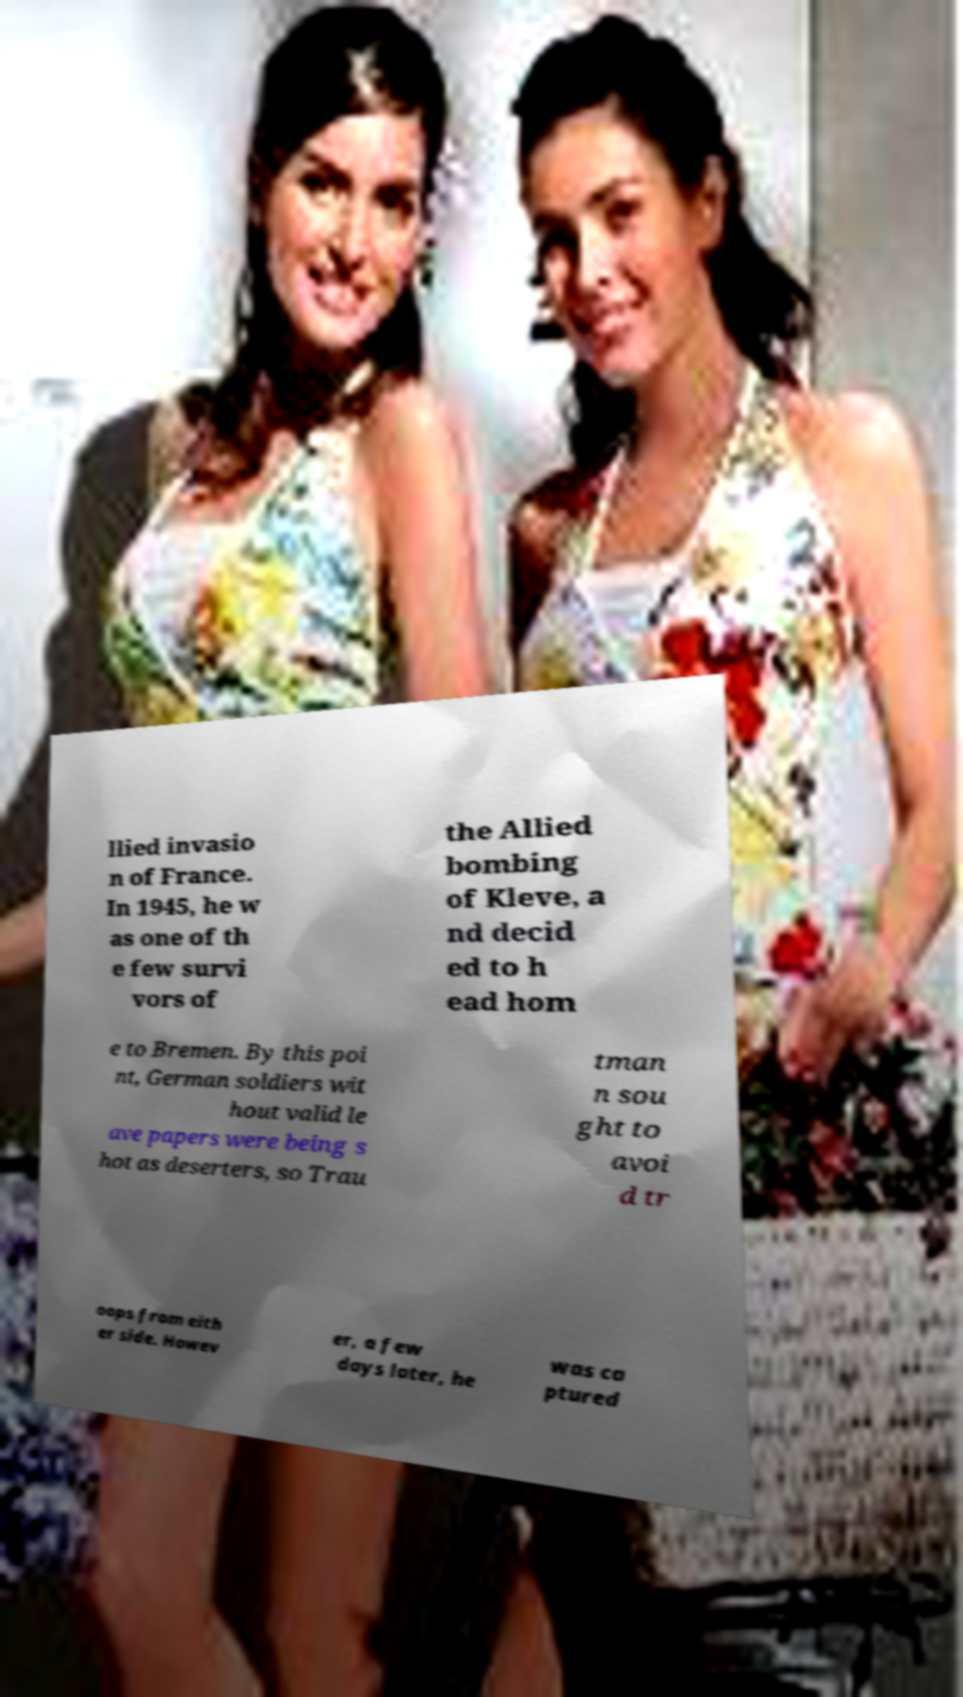Please identify and transcribe the text found in this image. llied invasio n of France. In 1945, he w as one of th e few survi vors of the Allied bombing of Kleve, a nd decid ed to h ead hom e to Bremen. By this poi nt, German soldiers wit hout valid le ave papers were being s hot as deserters, so Trau tman n sou ght to avoi d tr oops from eith er side. Howev er, a few days later, he was ca ptured 